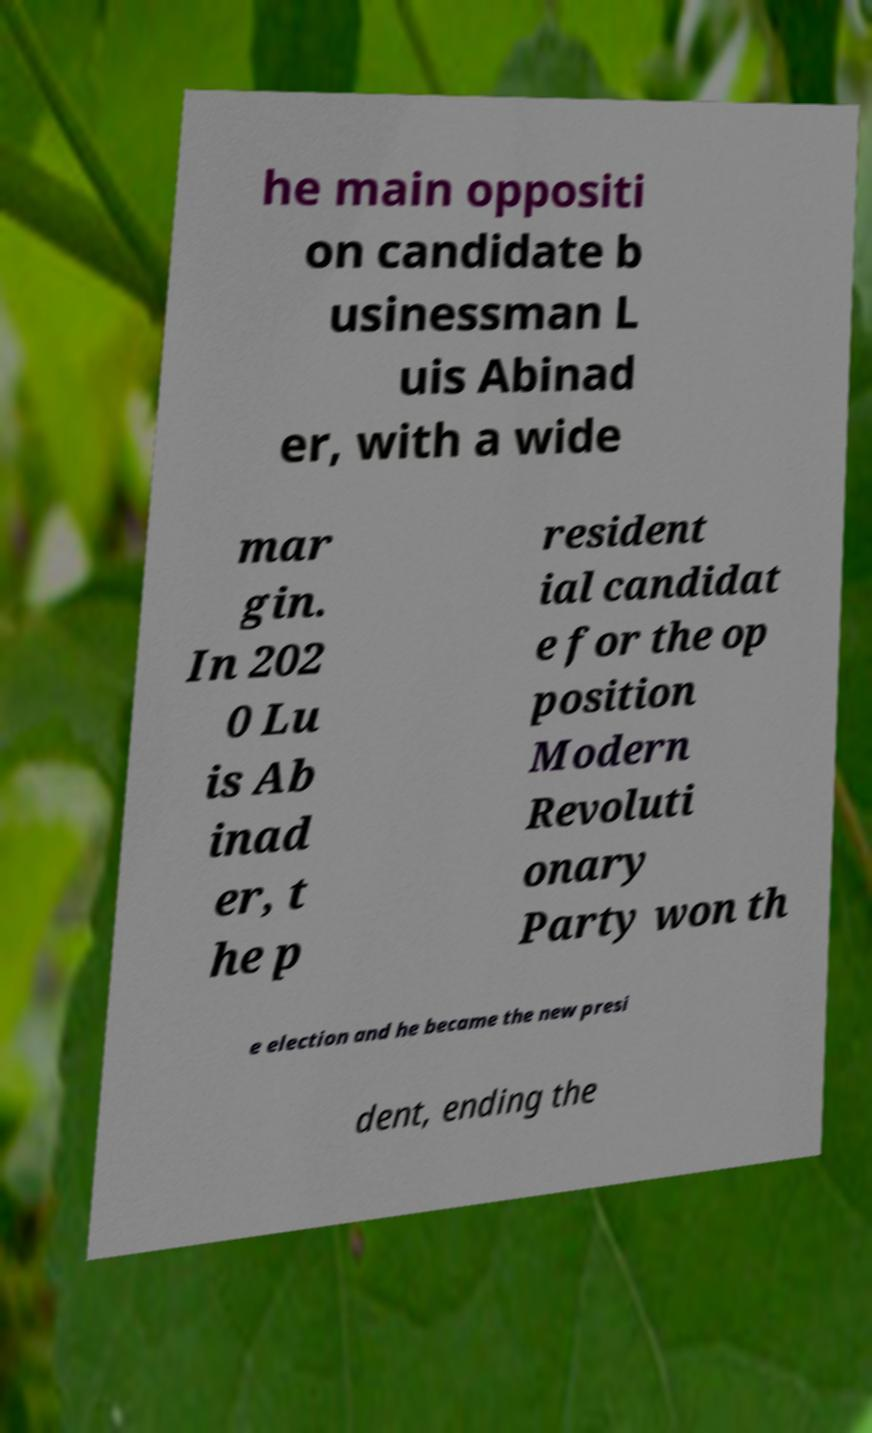Could you assist in decoding the text presented in this image and type it out clearly? he main oppositi on candidate b usinessman L uis Abinad er, with a wide mar gin. In 202 0 Lu is Ab inad er, t he p resident ial candidat e for the op position Modern Revoluti onary Party won th e election and he became the new presi dent, ending the 